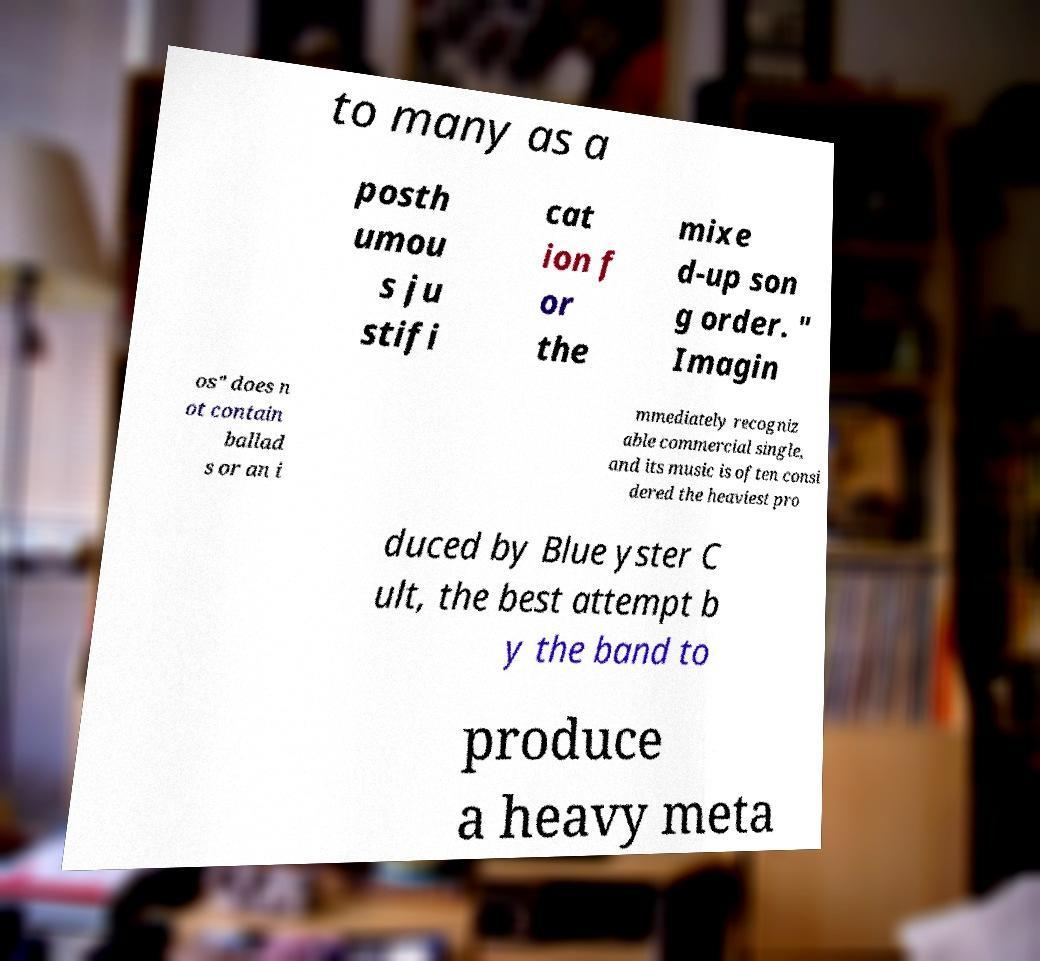Can you accurately transcribe the text from the provided image for me? to many as a posth umou s ju stifi cat ion f or the mixe d-up son g order. " Imagin os" does n ot contain ballad s or an i mmediately recogniz able commercial single, and its music is often consi dered the heaviest pro duced by Blue yster C ult, the best attempt b y the band to produce a heavy meta 